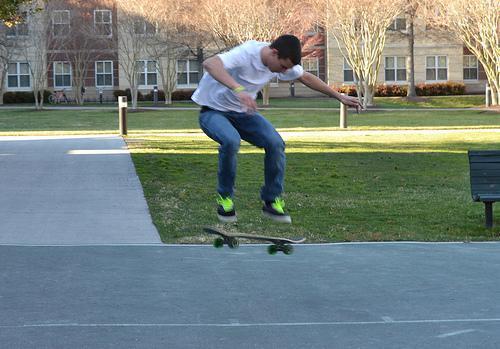How many people are in the picture?
Give a very brief answer. 1. 